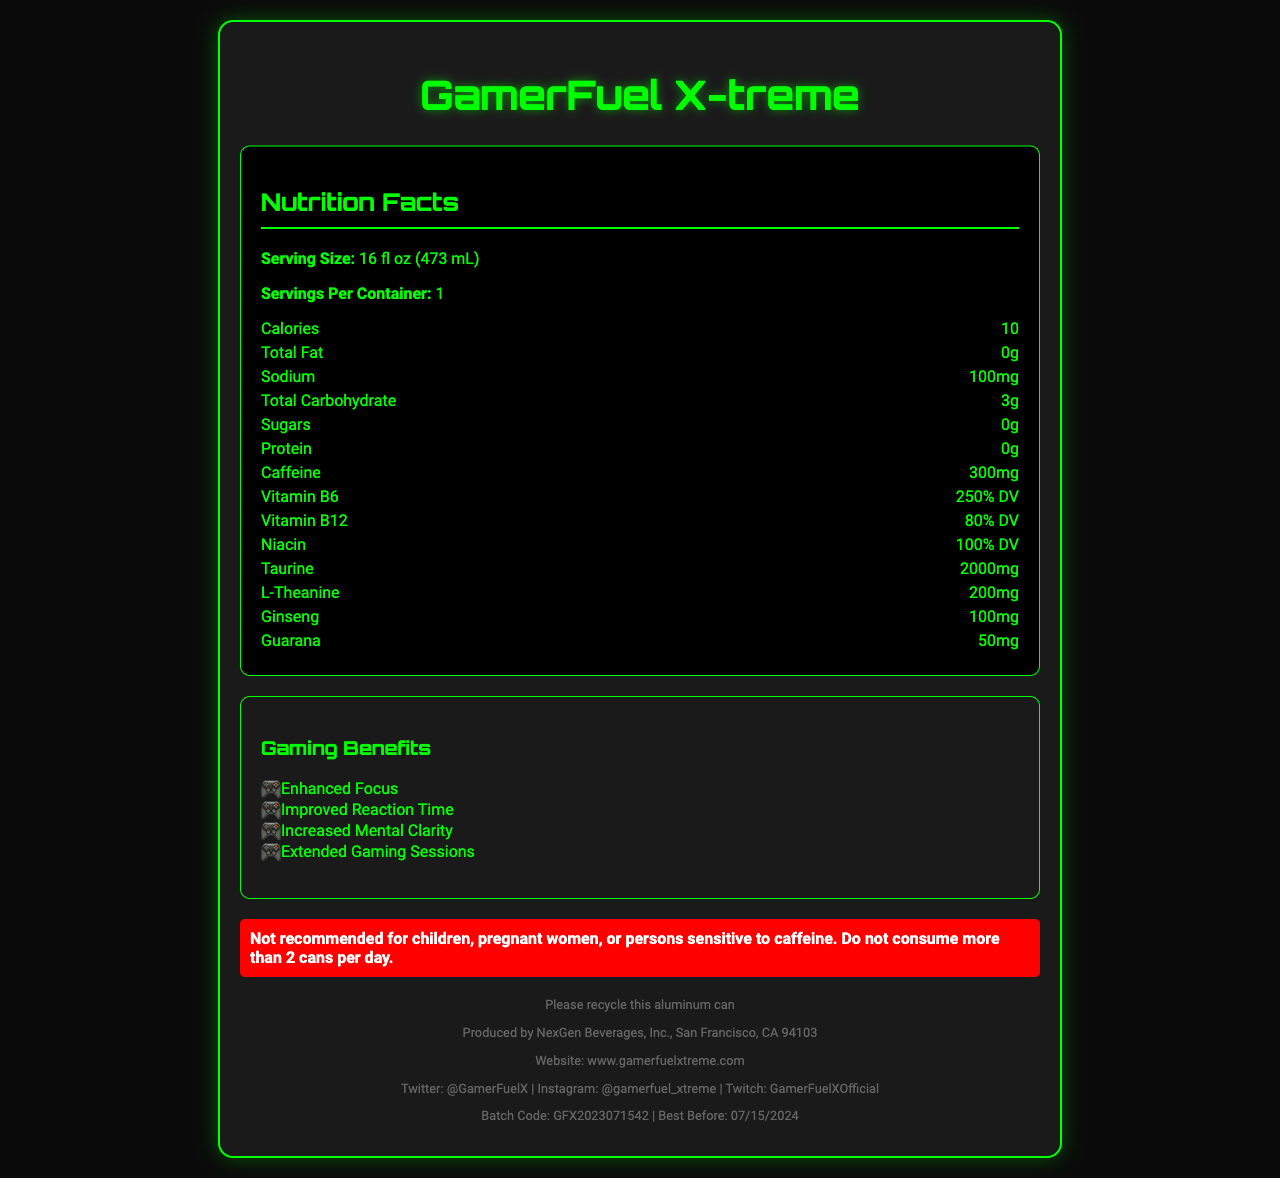what is the serving size of GamerFuel X-treme? The serving size is listed right under the "Nutrition Facts" section for GamerFuel X-treme.
Answer: 16 fl oz (473 mL) how many calories are in one serving? The number of calories per serving is mentioned in the nutrition facts as 10.
Answer: 10 what are the main gaming benefits of this energy drink? The gaming benefits are listed under the "Gaming Benefits" section.
Answer: Enhanced Focus, Improved Reaction Time, Increased Mental Clarity, Extended Gaming Sessions how much vitamin B6 is in one serving? The amount of vitamin B6 is listed in the nutrition facts section as 250% DV.
Answer: 250% DV how much caffeine does this drink contain? The amount of caffeine is clearly mentioned in the nutrition facts section as 300 mg.
Answer: 300 mg out of the listed gaming benefits, which one is NOT included? A. Better Graphics B. Enhanced Focus C. Improved Reaction Time "Better Graphics" is not listed under the "Gaming Benefits" section.
Answer: A. Better Graphics how many grams of sugars are there in this energy drink? The amount of sugar is defined in the nutrition facts as 0 g.
Answer: 0 g what is the recommended maximum daily consumption of this drink? The warning statement specifies not to consume more than 2 cans per day.
Answer: 2 cans per day which of the following vitamins is included in GamerFuel X-treme? I. Vitamin B6 II. Vitamin C III. Vitamin B12 The nutrition facts list Vitamin B6 and Vitamin B12 as ingredients, but Vitamin C is not listed.
Answer: I and III is this drink suitable for children? The warning statement clearly says it is not recommended for children.
Answer: No summarize the main elements of the GamerFuel X-treme nutrition facts label. The document provides detailed nutritional information, highlights the specific benefits for gamers, and includes important warnings and contact details.
Answer: GamerFuel X-treme is a high-caffeine energy drink with low calories (10 per serving) and no sugars. Key ingredients include taurine, L-theanine, ginseng, and guarana. It offers several gaming benefits such as enhanced focus and improved reaction time. It contains high levels of vitamins B6 and B12 and has a strong warning about consumption limits. what is the expiration date of the product? The expiration date is listed at the bottom of the document as "Best Before: 07/15/2024".
Answer: Best Before: 07/15/2024 does this product contain any allergens? The allergen information provided states that it is manufactured in a facility that processes common allergens.
Answer: Manufactured in a facility that processes milk, soy, and tree nuts are there any artificial ingredients in this drink? The "other ingredients" section lists artificial flavors and FD&C Blue #1, which is an artificial colorant.
Answer: Yes who produces GamerFuel X-treme? The manufacturer information states that it is produced by NexGen Beverages, Inc.
Answer: NexGen Beverages, Inc. which platform can you find GamerFuel X-treme on Twitch? The social media section specifies the Twitch handle as GamerFuelXOfficial.
Answer: GamerFuelXOfficial does the product include natural flavors? The "other ingredients" section lists both natural and artificial flavors.
Answer: Yes what is the batch code indicated on the document? The batch code is given at the bottom of the document as GFX2023071542.
Answer: GFX2023071542 